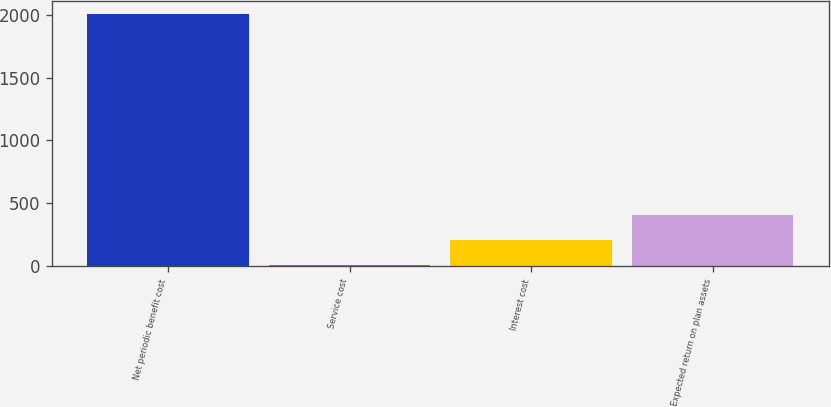<chart> <loc_0><loc_0><loc_500><loc_500><bar_chart><fcel>Net periodic benefit cost<fcel>Service cost<fcel>Interest cost<fcel>Expected return on plan assets<nl><fcel>2008<fcel>8<fcel>208<fcel>408<nl></chart> 